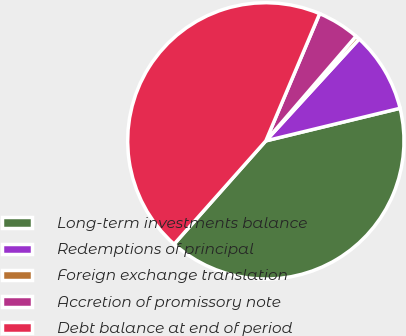Convert chart to OTSL. <chart><loc_0><loc_0><loc_500><loc_500><pie_chart><fcel>Long-term investments balance<fcel>Redemptions of principal<fcel>Foreign exchange translation<fcel>Accretion of promissory note<fcel>Debt balance at end of period<nl><fcel>40.35%<fcel>9.41%<fcel>0.48%<fcel>4.95%<fcel>44.81%<nl></chart> 